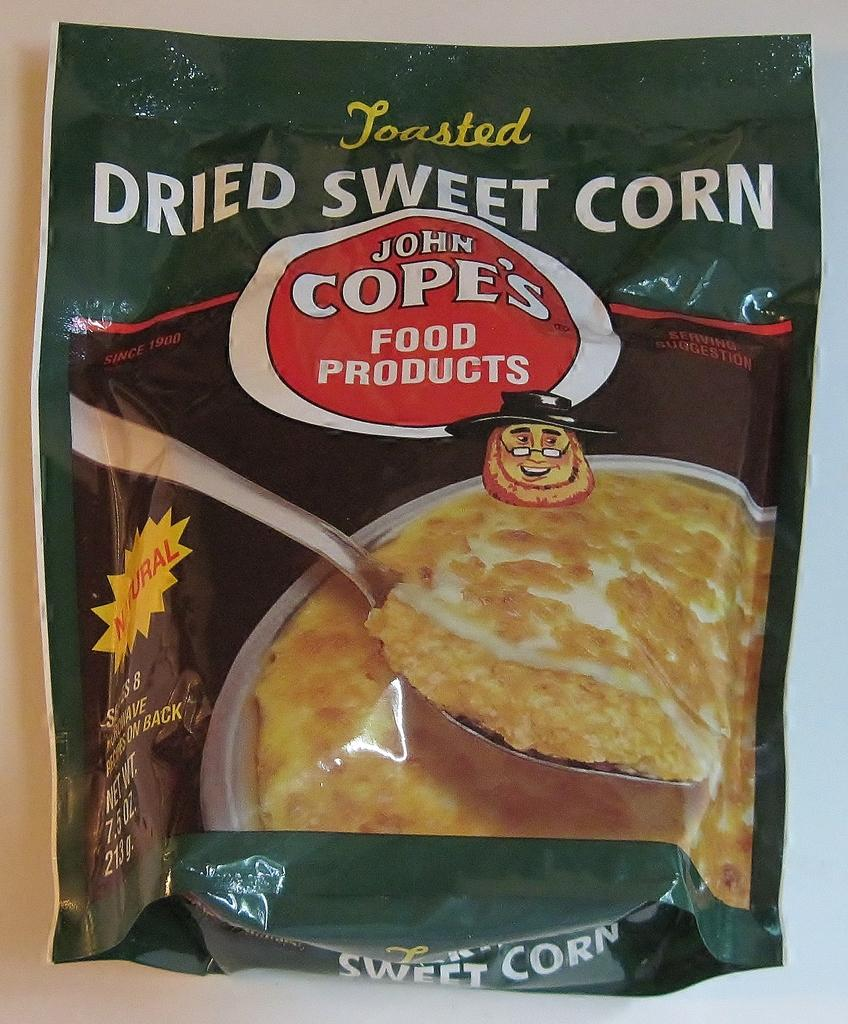What is present in the image that contains food products? There is a packet in the image that contains food products. What additional information can be found on the packet? There is text and a photo on the packet. How many locks are present on the packet in the image? There are no locks present on the packet in the image. What color are the eyes of the person in the photo on the packet? There is no person in the photo on the packet, and therefore no eyes to describe. 